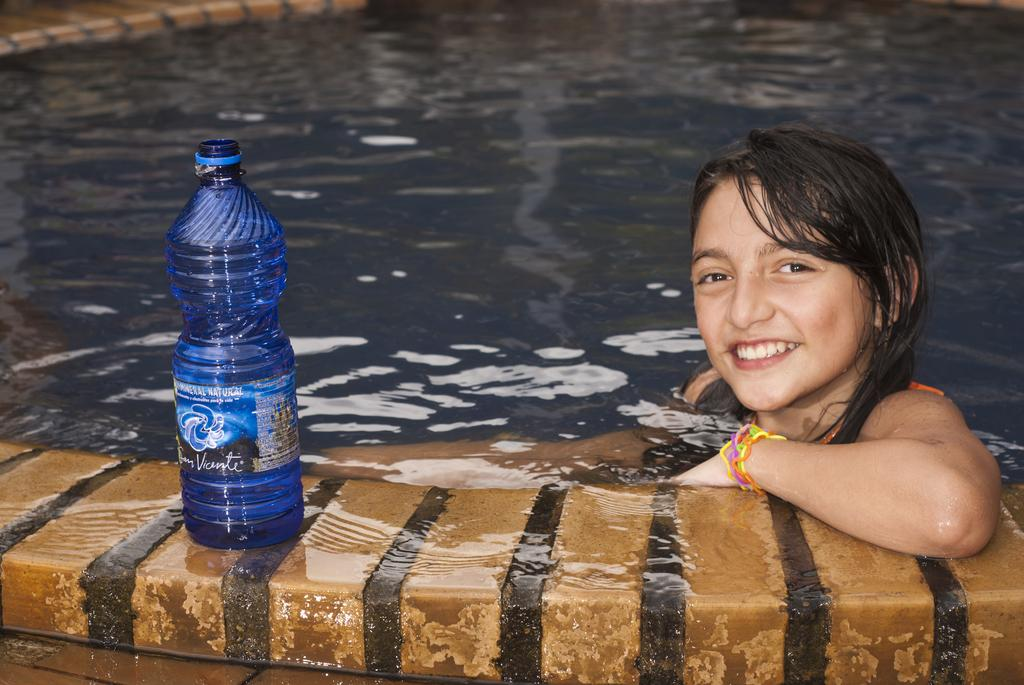What is the girl doing in the image? The girl is in a swimming pool. How does the girl appear to feel in the image? The girl is smiling, which suggests sheds light on her positive emotions. What object is visible in the image besides the girl? There is a water bottle visible in the image. What type of debt is the girl discussing with her friend in the image? There is no indication of a conversation about debt in the image, as it primarily focuses on the girl in the swimming pool and her smile. 